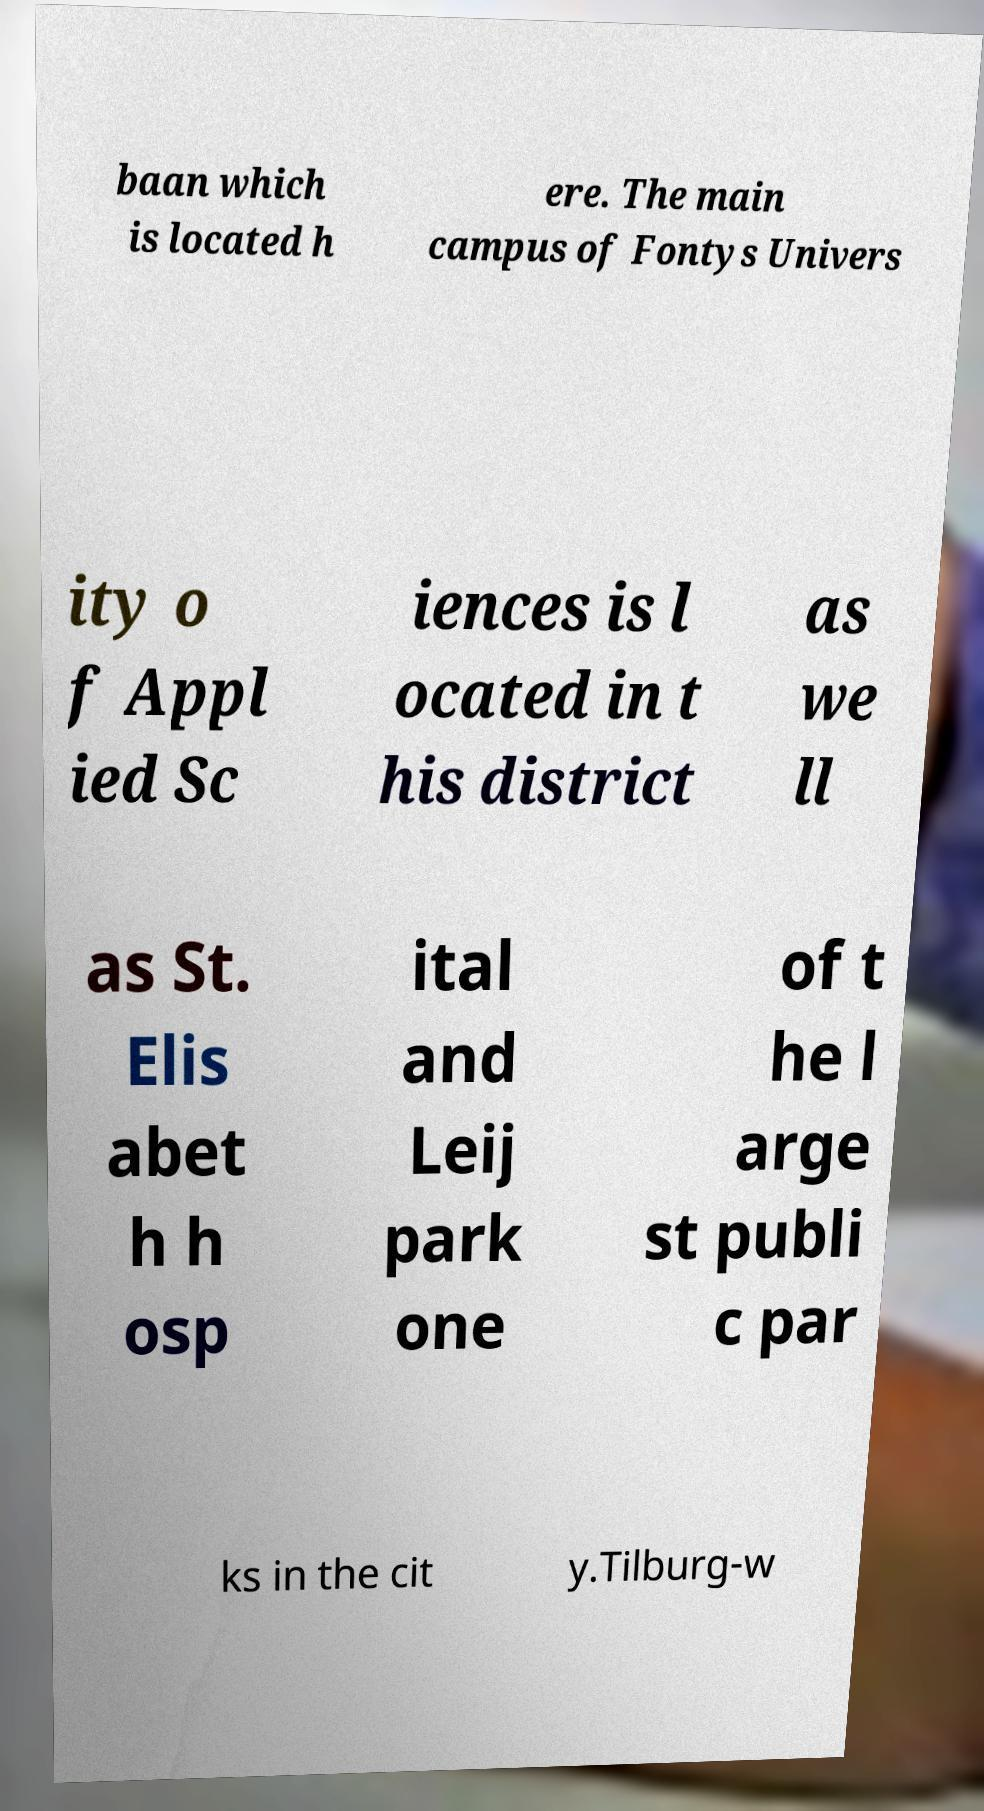Can you accurately transcribe the text from the provided image for me? baan which is located h ere. The main campus of Fontys Univers ity o f Appl ied Sc iences is l ocated in t his district as we ll as St. Elis abet h h osp ital and Leij park one of t he l arge st publi c par ks in the cit y.Tilburg-w 